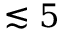Convert formula to latex. <formula><loc_0><loc_0><loc_500><loc_500>\lesssim 5</formula> 